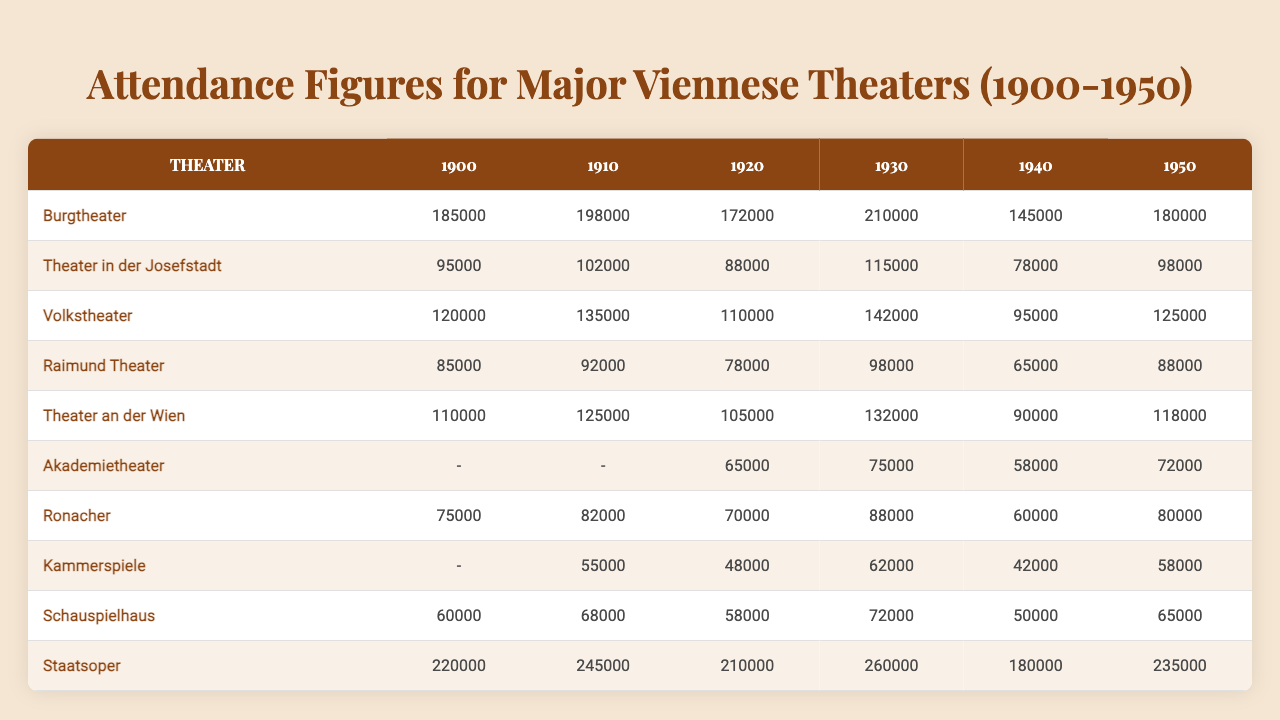What was the attendance figure for the Burgtheater in 1940? The table shows that the attendance figure for the Burgtheater in 1940 is 145,000.
Answer: 145,000 Which theater had the highest attendance in 1930? By looking at the 1930 column, the Staatsoper has the highest attendance figure at 260,000, compared to others like Burgtheater with 210,000.
Answer: Staatsoper What is the average attendance for the Theater in der Josefstadt from 1900 to 1950? To find the average, sum the attendance figures from 1900 to 1950: (95,000 + 102,000 + 88,000 + 115,000 + 78,000 + 98,000) = 576,000. Since there are 6 figures, the average is 576,000 / 6 = 96,000.
Answer: 96,000 Did the Volks theater ever have attendance figures below 100,000? From the table, the lowest figure for the Volks theater is 95,000 in 1940, which is below 100,000. Thus, yes, it had attendance below 100,000.
Answer: Yes What was the total attendance for all theaters in 1950? To find the total for 1950, add together all the figures: 180,000 (Burgtheater) + 98,000 (Theater in der Josefstadt) + 125,000 (Volkstheater) + 88,000 (Raimund Theater) + 118,000 (Theater an der Wien) + 72,000 (Akademietheater) + 80,000 (Ronacher) + 58,000 (Kammerspiele) + 65,000 (Schauspielhaus) + 235,000 (Staatsoper) = 1,084,000.
Answer: 1,084,000 Which theater showed the biggest increase in attendance from 1900 to 1950? To determine the biggest increase, we compare the starting numbers to those in 1950: The Burgtheater increased from 185,000 to 180,000 (decrease of 5,000), the Theater an der Wien from 110,000 to 118,000 (increase of 8,000), and the Staatsoper from 220,000 to 235,000 (increase of 15,000). The Staatsoper had the biggest increase in attendance.
Answer: Staatsoper What was the attendance figure for the Kammerspiele in 1900? In the table, the Kammerspiele does not have data for 1900, so it is represented as null, which means there's no available attendance figure for that year.
Answer: - How many theaters had attendance figures above 200,000 in 1940? In 1940, the only theater with attendance above 200,000 is the Staatsoper (180,000 - below) and the Burgtheater (145,000 - below). Thus, 0 theaters had attendance figures above 200,000.
Answer: 0 What was the change in attendance for the Raimund Theater from 1930 to 1940? The attendance in 1930 was 98,000, and in 1940 it was 65,000. The change is calculated as 65,000 - 98,000 = -33,000, indicating a decrease.
Answer: -33,000 Which years saw the Akademietheater attendance figures, and what were they? The Akademietheater has attendance figures for the years 1920 (65,000), 1930 (75,000), 1940 (58,000), and 1950 (72,000). In the years 1900 and 1910, there are no attendance figures, so they are null.
Answer: 65,000 (1920), 75,000 (1930), 58,000 (1940), 72,000 (1950) 